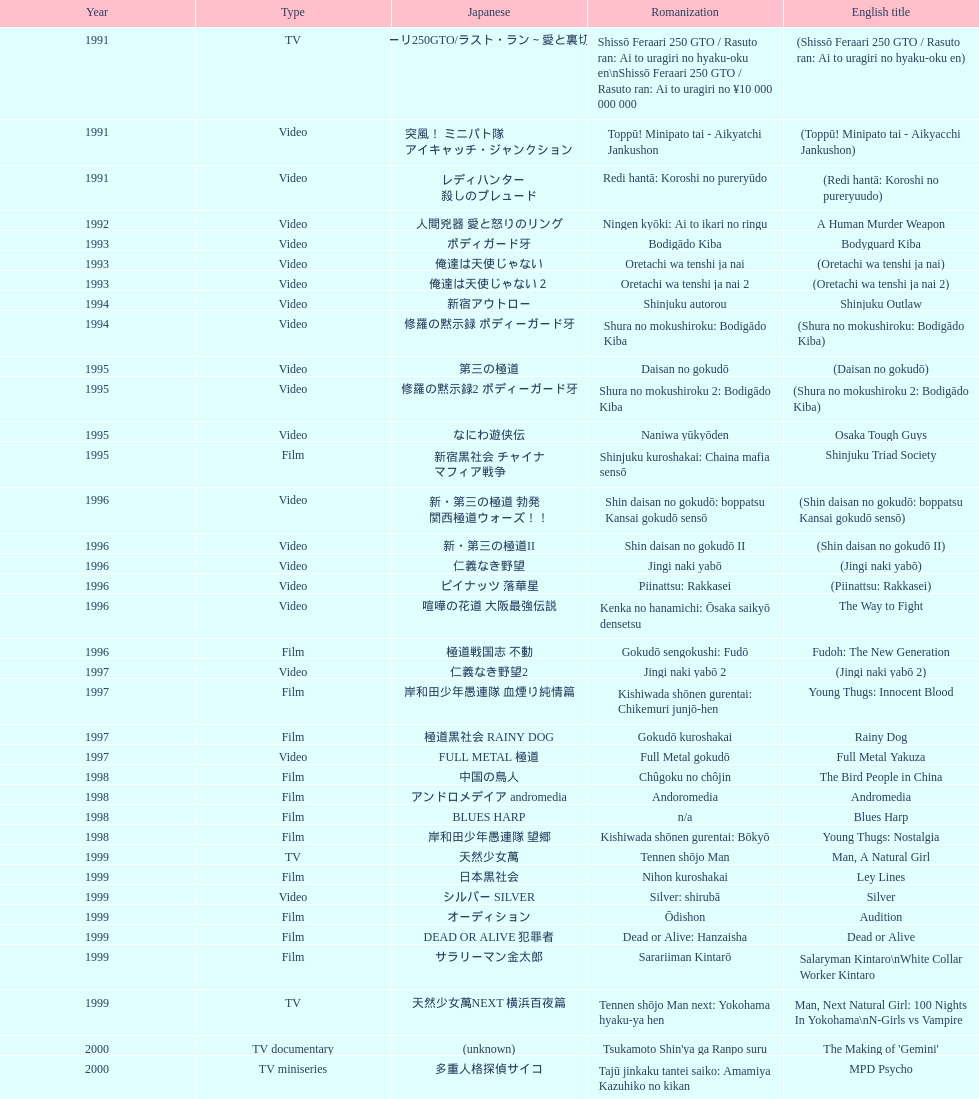Which title is listed next after "the way to fight"? Fudoh: The New Generation. 